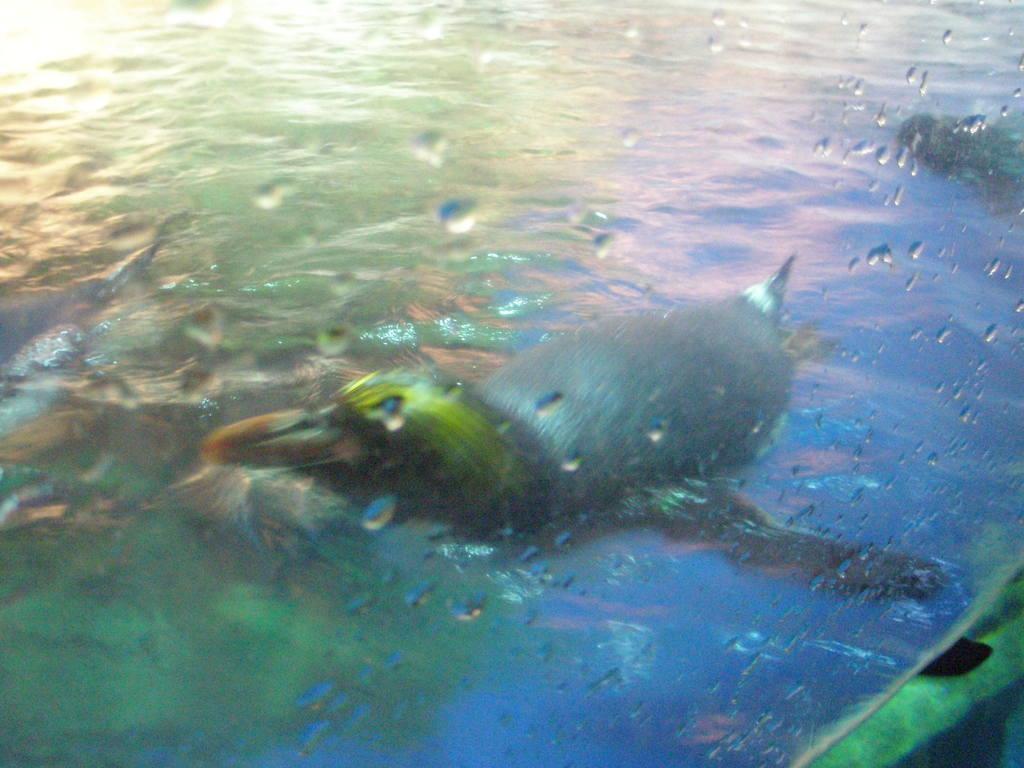How would you summarize this image in a sentence or two? In this picture we can see birds in the water. 